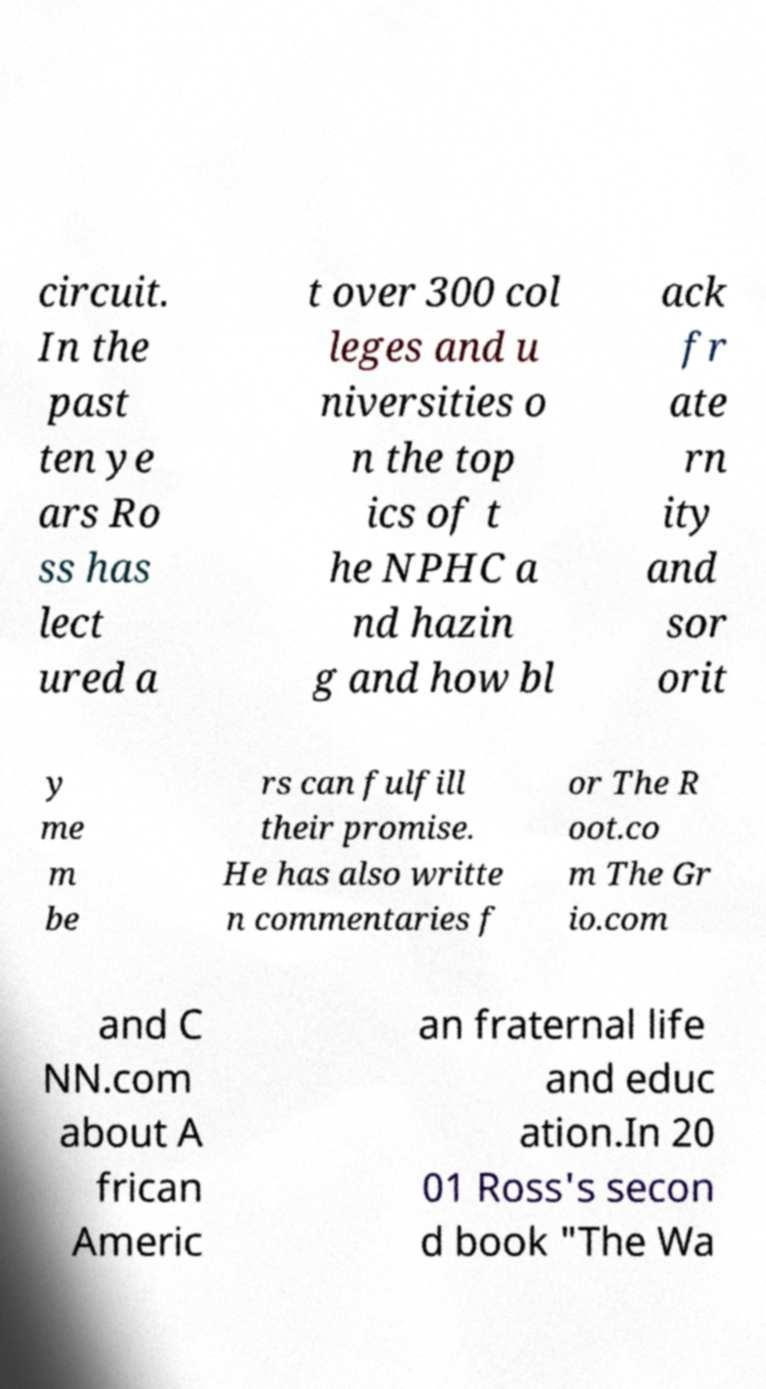There's text embedded in this image that I need extracted. Can you transcribe it verbatim? circuit. In the past ten ye ars Ro ss has lect ured a t over 300 col leges and u niversities o n the top ics of t he NPHC a nd hazin g and how bl ack fr ate rn ity and sor orit y me m be rs can fulfill their promise. He has also writte n commentaries f or The R oot.co m The Gr io.com and C NN.com about A frican Americ an fraternal life and educ ation.In 20 01 Ross's secon d book "The Wa 